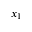<formula> <loc_0><loc_0><loc_500><loc_500>x _ { 1 }</formula> 